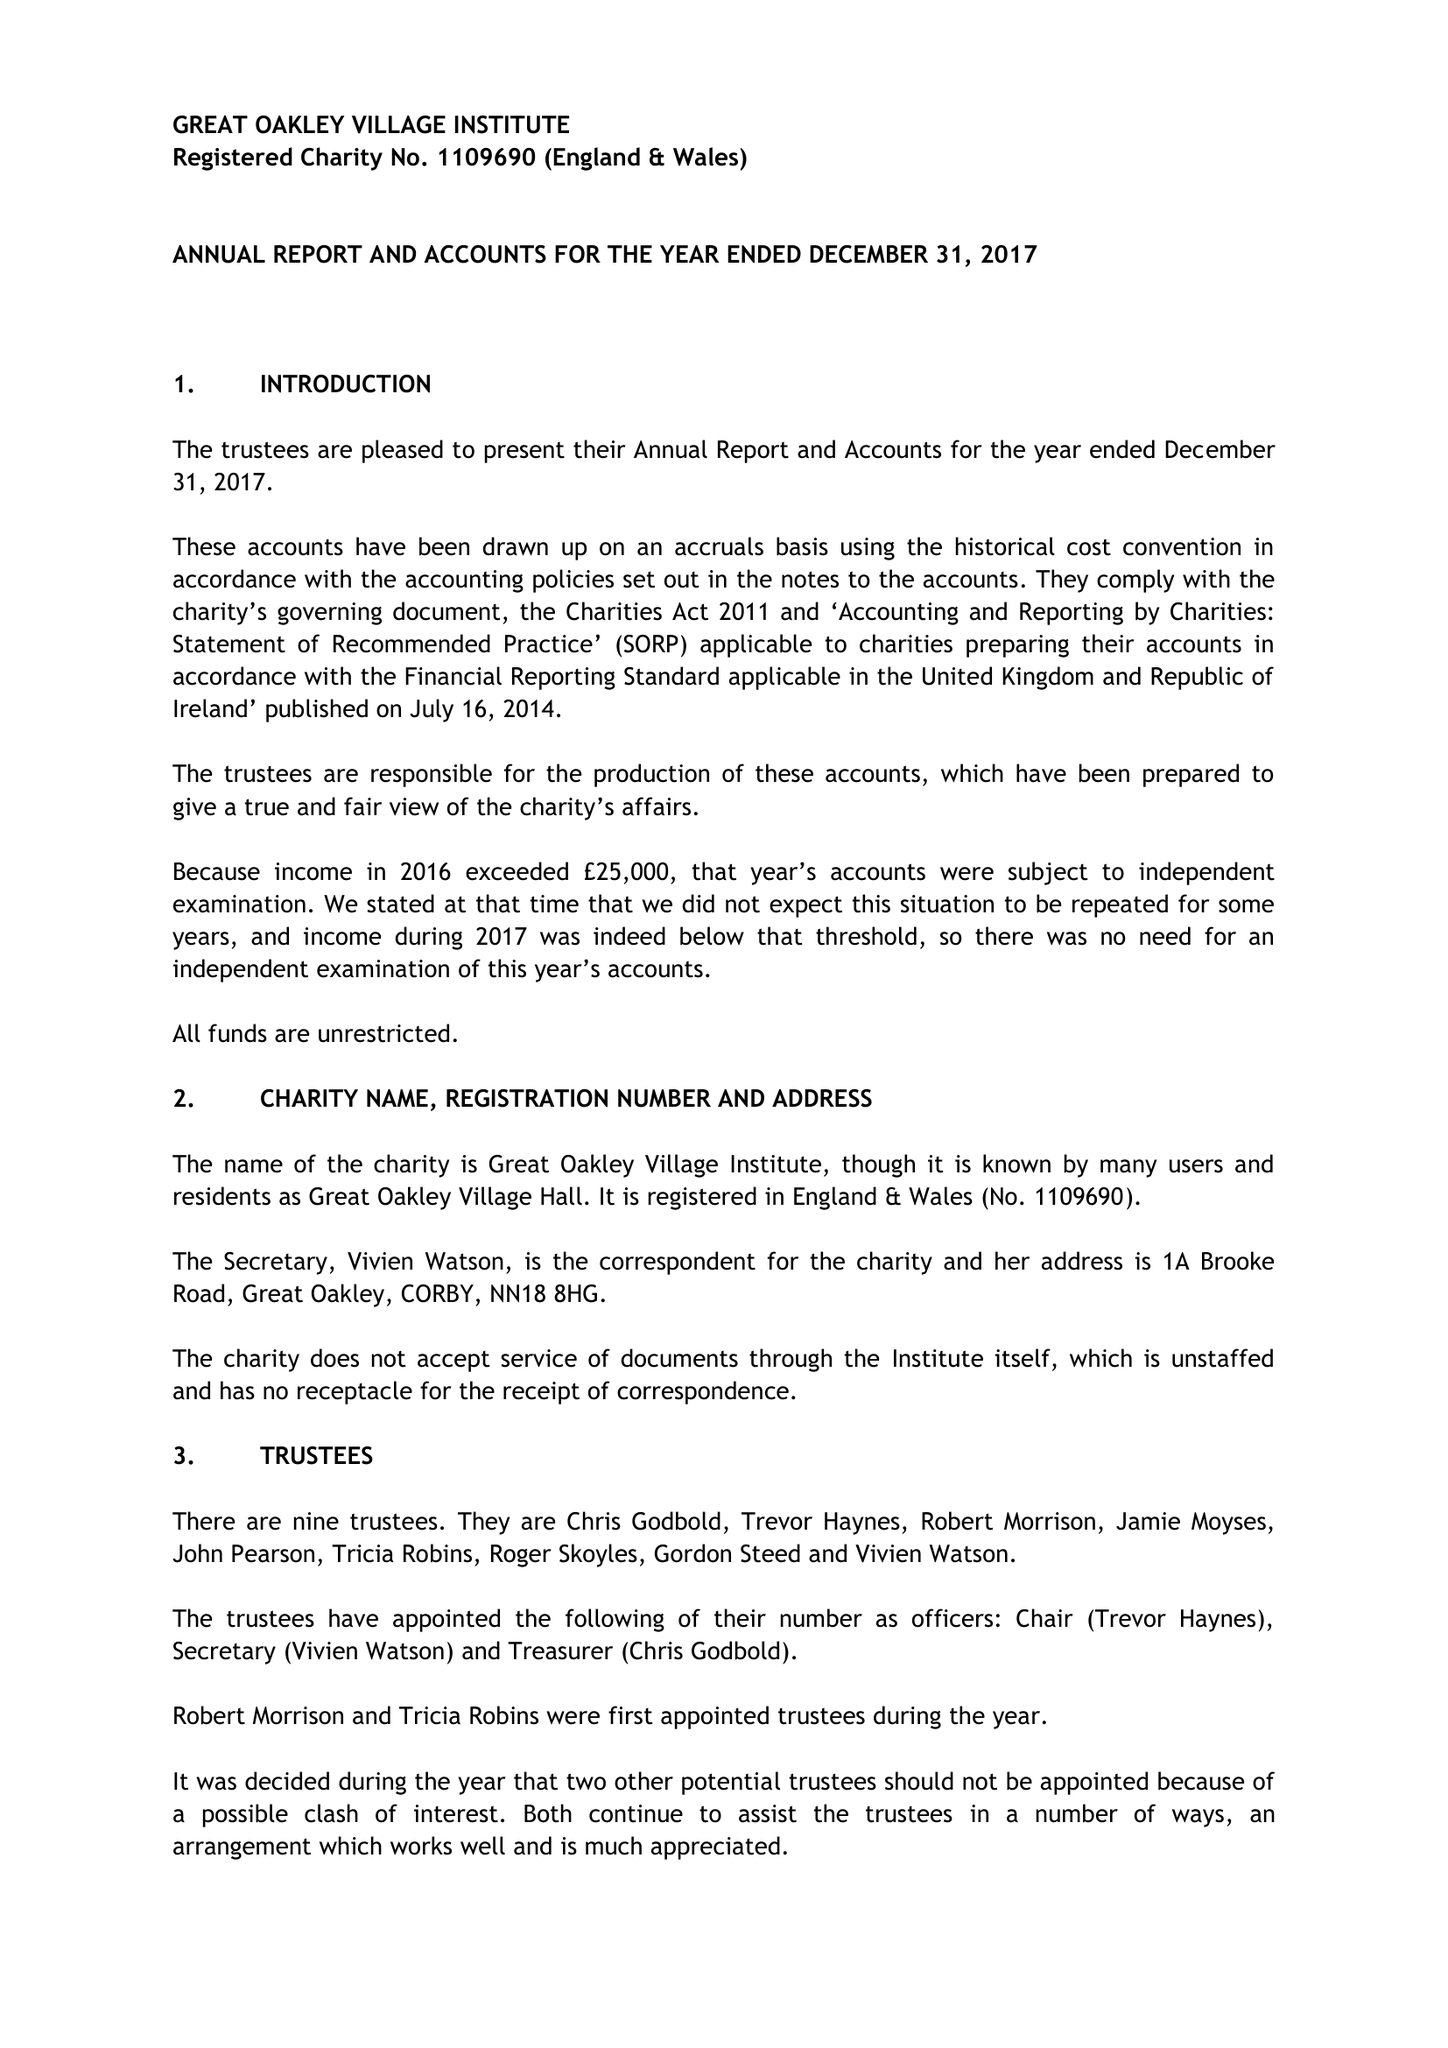What is the value for the charity_number?
Answer the question using a single word or phrase. 1109690 